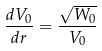<formula> <loc_0><loc_0><loc_500><loc_500>\frac { d V _ { 0 } } { d r } = \frac { \sqrt { W _ { 0 } } } { V _ { 0 } }</formula> 